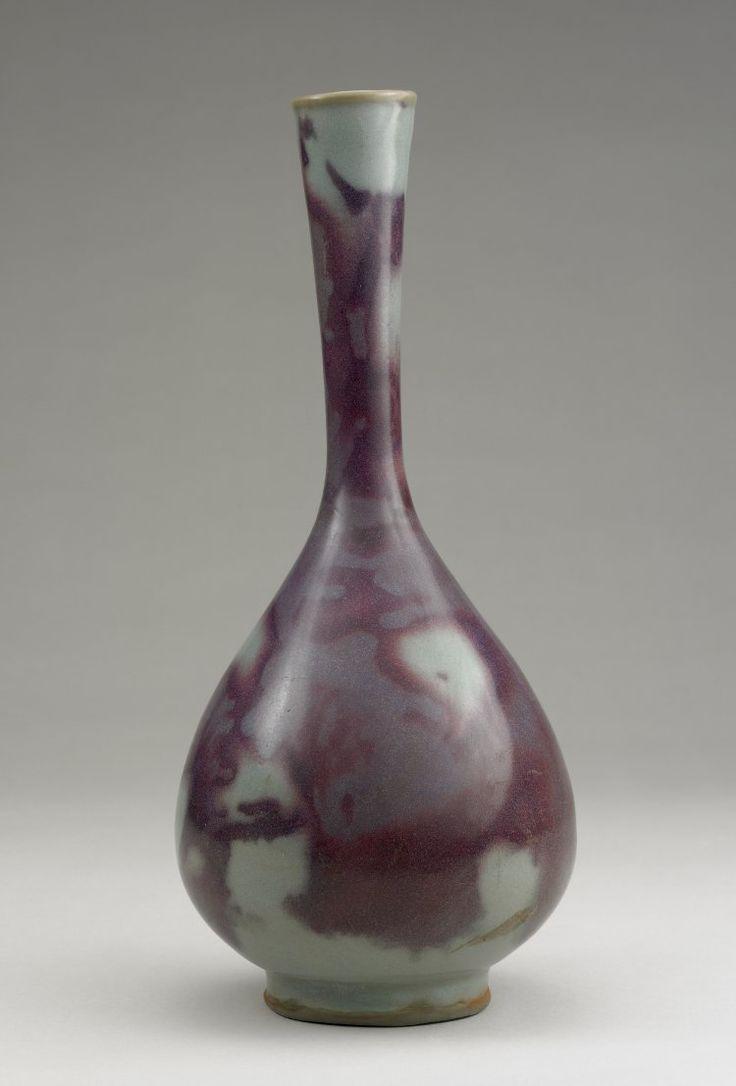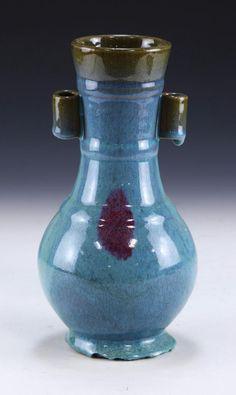The first image is the image on the left, the second image is the image on the right. Evaluate the accuracy of this statement regarding the images: "One of the images shows a purple vase while the vase in the other image is mostly blue.". Is it true? Answer yes or no. Yes. The first image is the image on the left, the second image is the image on the right. Analyze the images presented: Is the assertion "A solid blue vase with no markings or texture is in in the right image." valid? Answer yes or no. No. 